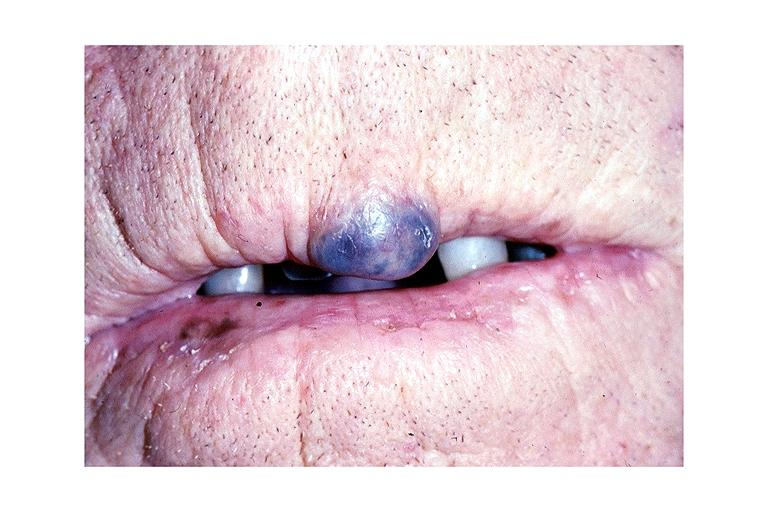does cord show hemangioma?
Answer the question using a single word or phrase. No 